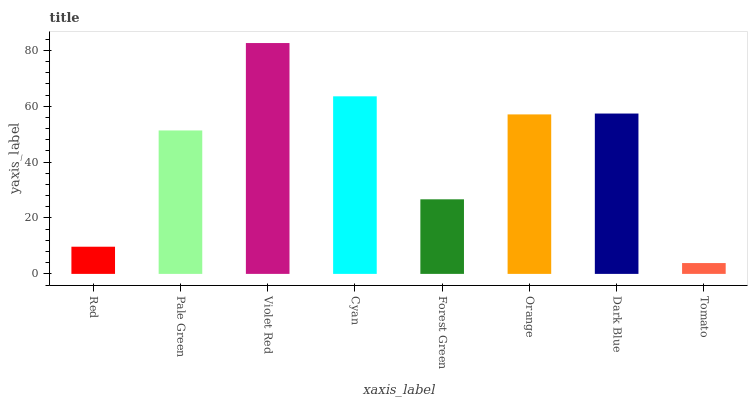Is Tomato the minimum?
Answer yes or no. Yes. Is Violet Red the maximum?
Answer yes or no. Yes. Is Pale Green the minimum?
Answer yes or no. No. Is Pale Green the maximum?
Answer yes or no. No. Is Pale Green greater than Red?
Answer yes or no. Yes. Is Red less than Pale Green?
Answer yes or no. Yes. Is Red greater than Pale Green?
Answer yes or no. No. Is Pale Green less than Red?
Answer yes or no. No. Is Orange the high median?
Answer yes or no. Yes. Is Pale Green the low median?
Answer yes or no. Yes. Is Pale Green the high median?
Answer yes or no. No. Is Orange the low median?
Answer yes or no. No. 